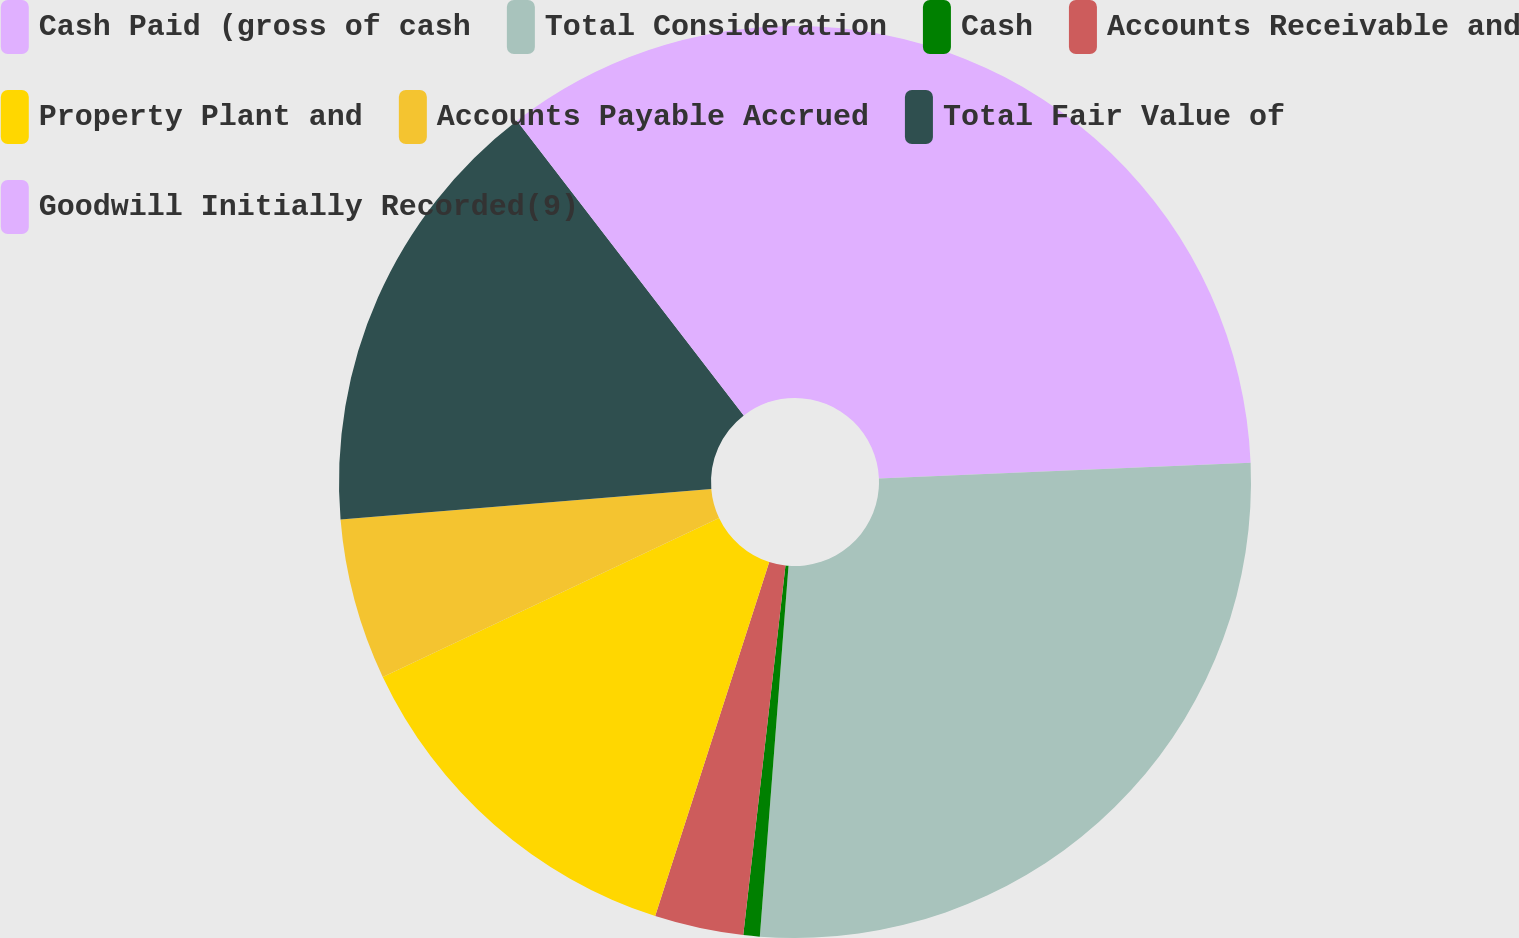Convert chart. <chart><loc_0><loc_0><loc_500><loc_500><pie_chart><fcel>Cash Paid (gross of cash<fcel>Total Consideration<fcel>Cash<fcel>Accounts Receivable and<fcel>Property Plant and<fcel>Accounts Payable Accrued<fcel>Total Fair Value of<fcel>Goodwill Initially Recorded(9)<nl><fcel>24.33%<fcel>26.9%<fcel>0.58%<fcel>3.15%<fcel>13.01%<fcel>5.72%<fcel>15.87%<fcel>10.44%<nl></chart> 